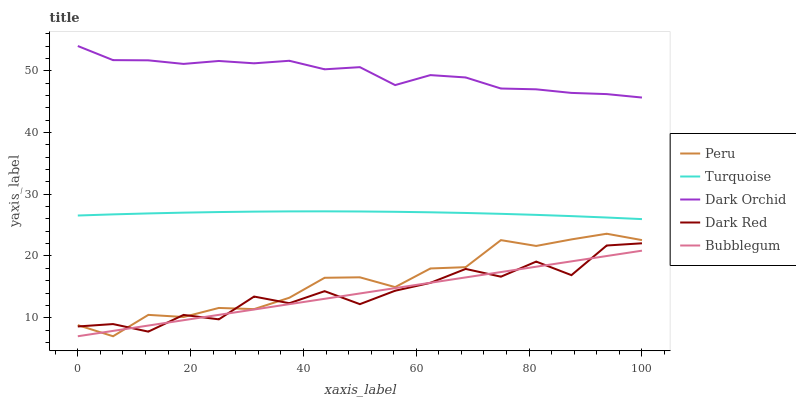Does Bubblegum have the minimum area under the curve?
Answer yes or no. Yes. Does Dark Orchid have the maximum area under the curve?
Answer yes or no. Yes. Does Turquoise have the minimum area under the curve?
Answer yes or no. No. Does Turquoise have the maximum area under the curve?
Answer yes or no. No. Is Bubblegum the smoothest?
Answer yes or no. Yes. Is Dark Red the roughest?
Answer yes or no. Yes. Is Turquoise the smoothest?
Answer yes or no. No. Is Turquoise the roughest?
Answer yes or no. No. Does Bubblegum have the lowest value?
Answer yes or no. Yes. Does Turquoise have the lowest value?
Answer yes or no. No. Does Dark Orchid have the highest value?
Answer yes or no. Yes. Does Turquoise have the highest value?
Answer yes or no. No. Is Dark Red less than Dark Orchid?
Answer yes or no. Yes. Is Dark Orchid greater than Peru?
Answer yes or no. Yes. Does Dark Red intersect Peru?
Answer yes or no. Yes. Is Dark Red less than Peru?
Answer yes or no. No. Is Dark Red greater than Peru?
Answer yes or no. No. Does Dark Red intersect Dark Orchid?
Answer yes or no. No. 